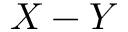Convert formula to latex. <formula><loc_0><loc_0><loc_500><loc_500>X - Y</formula> 